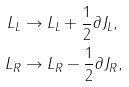<formula> <loc_0><loc_0><loc_500><loc_500>L _ { L } & \rightarrow L _ { L } + \frac { 1 } { 2 } \partial J _ { L } , \\ L _ { R } & \rightarrow L _ { R } - \frac { 1 } { 2 } \partial J _ { R } ,</formula> 